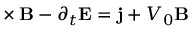Convert formula to latex. <formula><loc_0><loc_0><loc_500><loc_500>\nabla \times B - \partial _ { t } E = j + V _ { 0 } B</formula> 